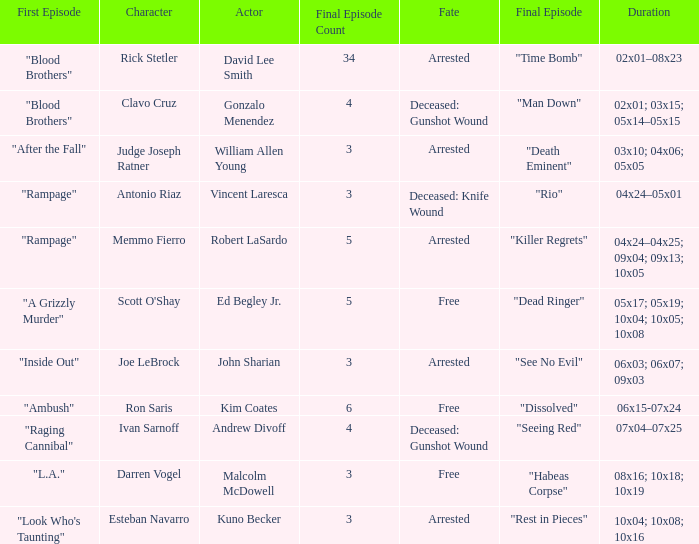What are all the actor where first episode is "ambush" Kim Coates. 